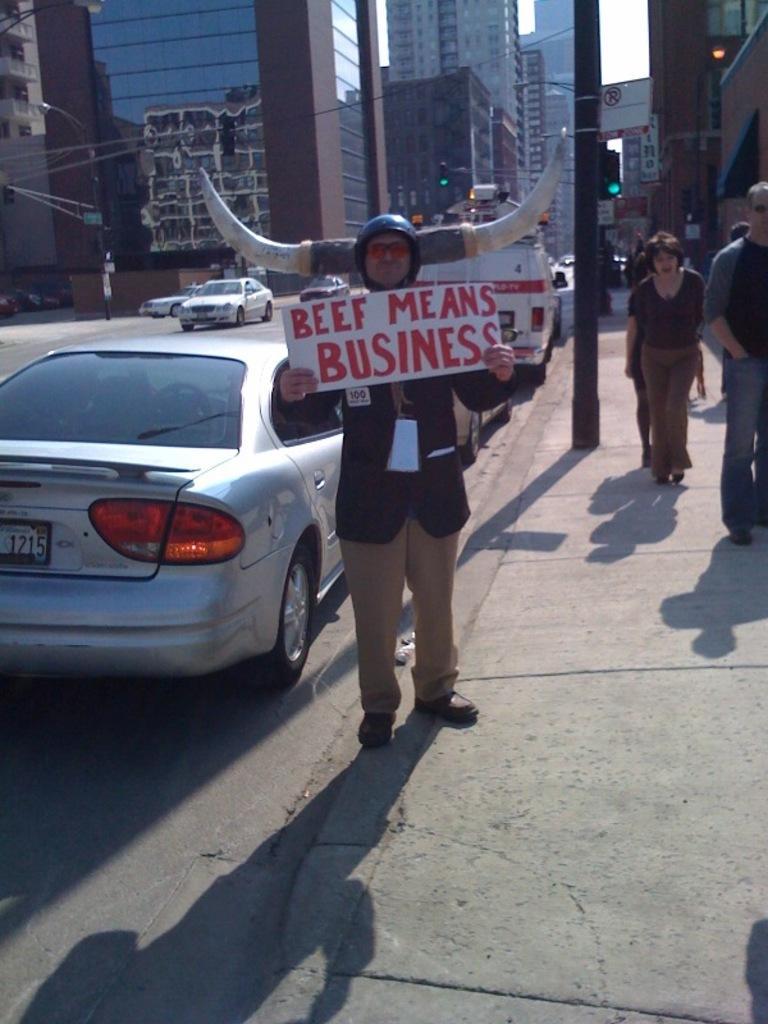In one or two sentences, can you explain what this image depicts? In this image there is a person standing and holding a board , and there are group of people walking on the side walk , and in the background there are vehicles on the road, buildings,sky. 